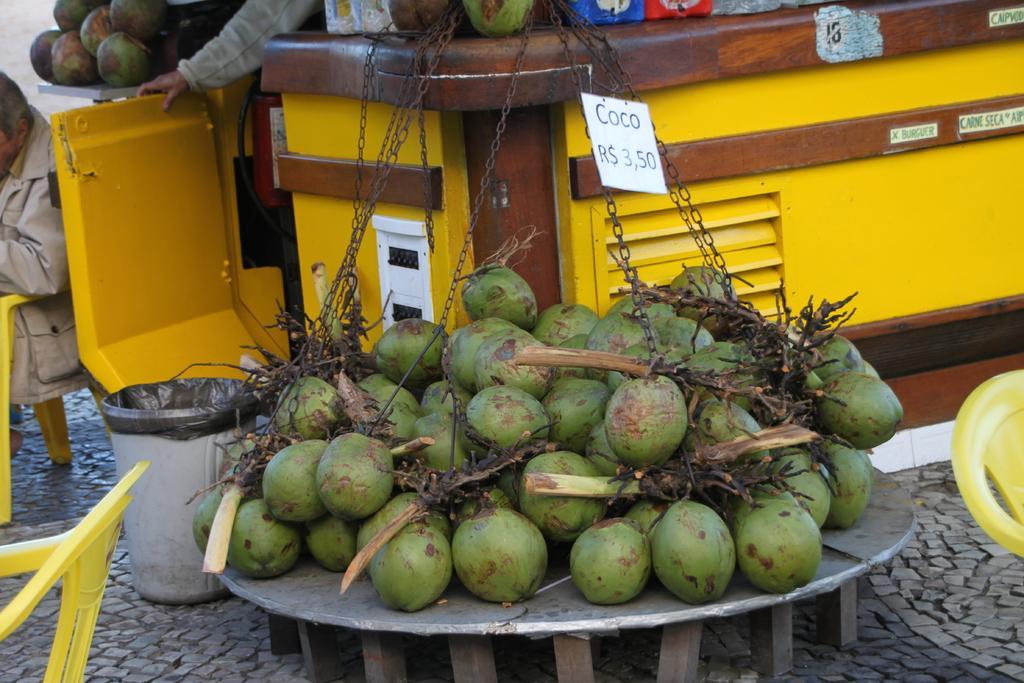Can you describe this image briefly? In this image there are coconuts and there are persons, there are empty chairs and there is a dustbin and there are is are objects in the center. 